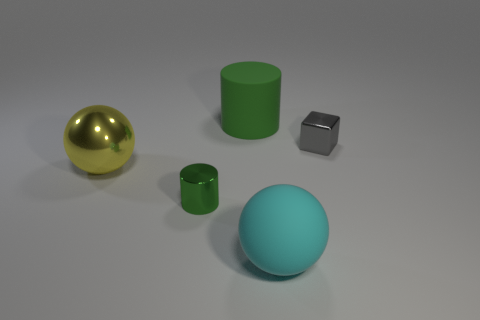Do the matte thing that is to the left of the cyan ball and the metal thing that is in front of the big shiny object have the same color?
Your answer should be very brief. Yes. What shape is the big rubber thing that is in front of the green rubber thing?
Ensure brevity in your answer.  Sphere. The metallic cube is what color?
Make the answer very short. Gray. What is the shape of the tiny green thing that is made of the same material as the big yellow ball?
Provide a succinct answer. Cylinder. Does the cylinder in front of the rubber cylinder have the same size as the yellow shiny thing?
Keep it short and to the point. No. How many things are either small gray metallic cubes that are right of the big green matte object or big rubber things in front of the gray block?
Your answer should be very brief. 2. There is a rubber thing on the left side of the cyan matte sphere; is its color the same as the shiny cylinder?
Ensure brevity in your answer.  Yes. What number of metal things are either yellow balls or small gray cubes?
Offer a terse response. 2. What is the shape of the large yellow metal object?
Offer a terse response. Sphere. Is there anything else that is made of the same material as the large green thing?
Give a very brief answer. Yes. 